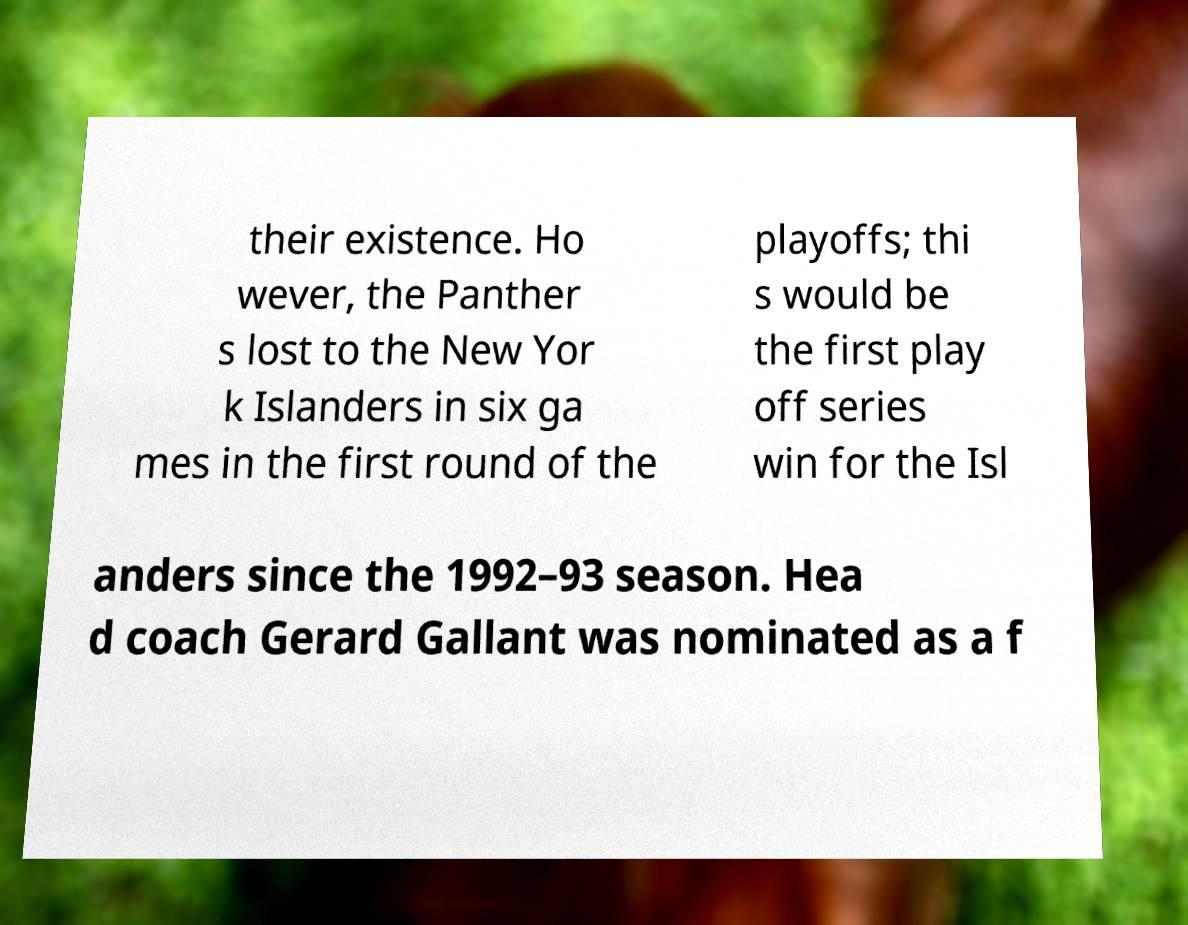Could you assist in decoding the text presented in this image and type it out clearly? their existence. Ho wever, the Panther s lost to the New Yor k Islanders in six ga mes in the first round of the playoffs; thi s would be the first play off series win for the Isl anders since the 1992–93 season. Hea d coach Gerard Gallant was nominated as a f 